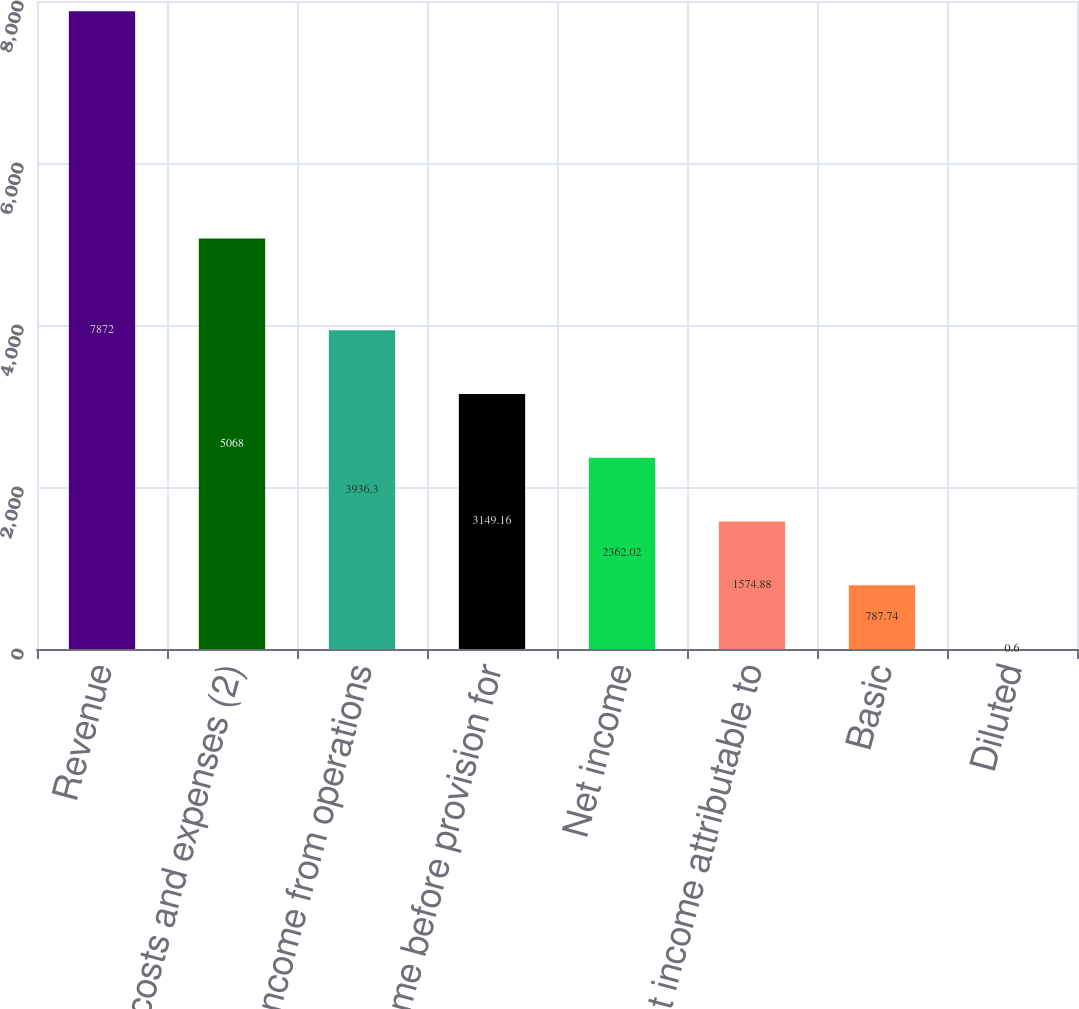Convert chart to OTSL. <chart><loc_0><loc_0><loc_500><loc_500><bar_chart><fcel>Revenue<fcel>Total costs and expenses (2)<fcel>Income from operations<fcel>Income before provision for<fcel>Net income<fcel>Net income attributable to<fcel>Basic<fcel>Diluted<nl><fcel>7872<fcel>5068<fcel>3936.3<fcel>3149.16<fcel>2362.02<fcel>1574.88<fcel>787.74<fcel>0.6<nl></chart> 